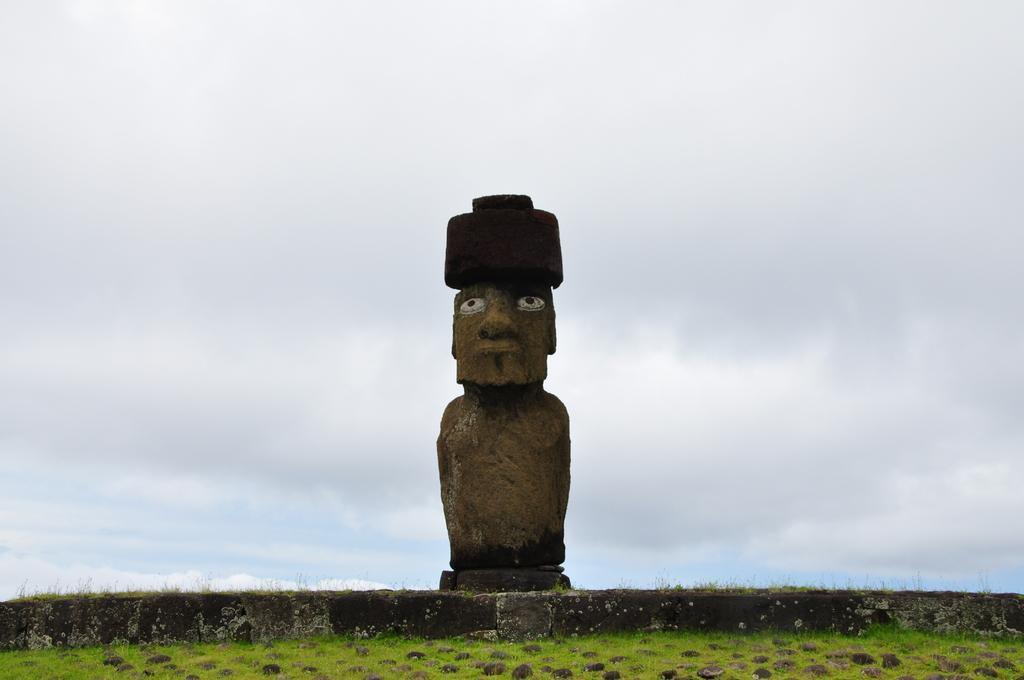In one or two sentences, can you explain what this image depicts? In this image there is the sky, there is sculptor of a person, there are plants, there is grass truncated towards the bottom of the image. 